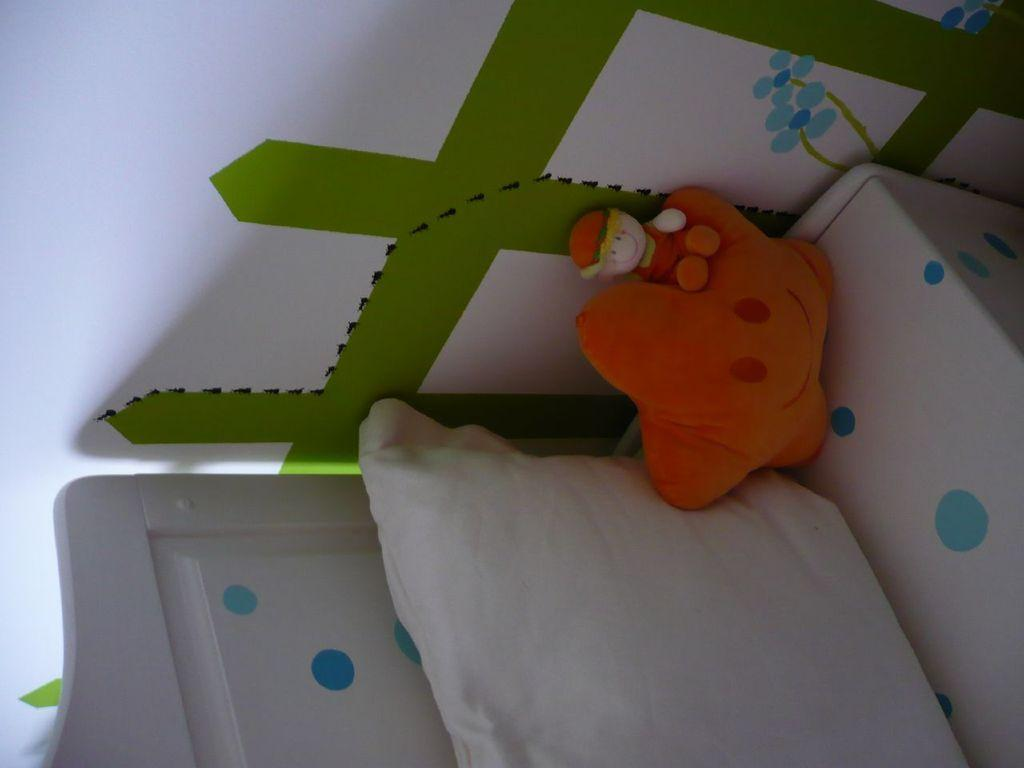How is the image oriented? The image is rotated towards the right. What objects can be seen on the floor in the image? There are two pillows on the floor in the image. What type of structure is visible in the background of the image? There is a wall in the image. What type of furniture is present in the image? There is a wooden table in the image. How many eggs are on the wooden table in the image? There are no eggs visible on the wooden table in the image. What type of respect is shown towards the wall in the image? The image does not convey any specific type of respect towards the wall; it simply depicts the wall as a background element. 